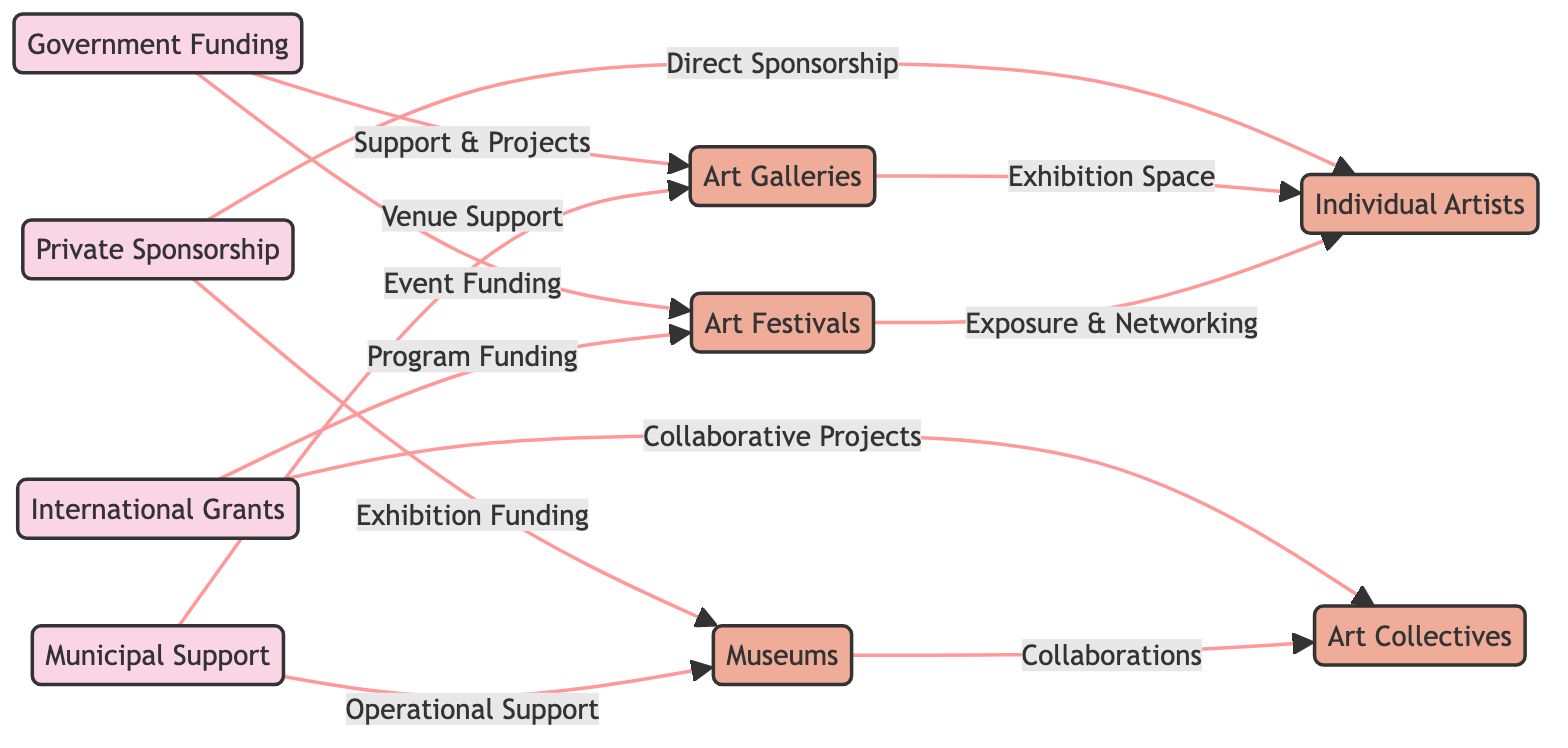What are the main sources of funding in Istanbul's art scene? By examining the nodes labeled with "funding," we can identify four primary sources: Government Funding, Private Sponsorship, International Grants, and Municipal Support.
Answer: Government Funding, Private Sponsorship, International Grants, Municipal Support Which recipient category receives exhibition funding? Looking at the edges connecting the funding sources to the recipients, "Exhibition Funding" specifically flows from "Private Sponsorship" to "Museums."
Answer: Museums How many types of recipient categories are shown in the diagram? Counting the recipient nodes, we identify five categories: Art Galleries, Art Festivals, Museums, Individual Artists, and Art Collectives. Thus, there are a total of five types of recipients.
Answer: 5 What type of support do art galleries receive from municipal funding? The connection indicates that "Municipal Support" is linked to "Art Galleries" through the edge labeled "Venue Support." This means that art galleries receive venue-related assistance from municipal support.
Answer: Venue Support Which funding source is associated with exposure and networking for individual artists? Tracing the diagram shows that "Art Festivals" provide exposure and networking opportunities for "Individual Artists," which in turn receives funding from both "Government Funding" and "International Grants."
Answer: Art Festivals What relationship connects individual artists to art galleries? The diagram indicates a connection where "Art Galleries" provide "Exhibition Space" for "Individual Artists." This denotes a supportive relationship where artists are given space to showcase their works.
Answer: Exhibition Space Which funding source is linked to operational support for museums? The edge leading from "Municipal Support" to "Museums" is labeled with "Operational Support," indicating that museums benefit from this specific type of funding.
Answer: Operational Support How does international grants support art collectives? According to the diagram, "International Grants" connect to "Art Collectives" through funding for "Collaborative Projects," indicating the nature of support provided to art collectives.
Answer: Collaborative Projects 